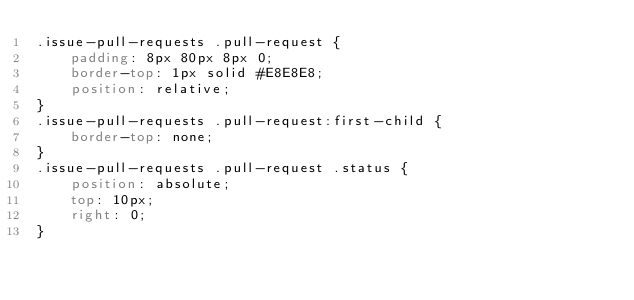Convert code to text. <code><loc_0><loc_0><loc_500><loc_500><_CSS_>.issue-pull-requests .pull-request {
    padding: 8px 80px 8px 0;
    border-top: 1px solid #E8E8E8;
    position: relative;
}
.issue-pull-requests .pull-request:first-child {
    border-top: none;
}
.issue-pull-requests .pull-request .status {
	position: absolute;
	top: 10px;
	right: 0;
}
</code> 